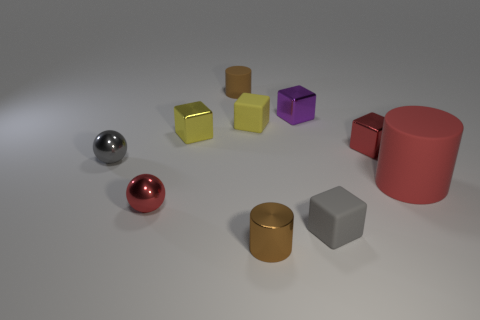What is the material of the large cylinder?
Provide a succinct answer. Rubber. There is a purple thing that is the same size as the gray sphere; what shape is it?
Your response must be concise. Cube. Is the small red object that is right of the yellow matte cube made of the same material as the brown object in front of the tiny purple cube?
Your answer should be compact. Yes. What number of small brown metallic objects are there?
Offer a terse response. 1. How many other matte objects are the same shape as the large red rubber object?
Ensure brevity in your answer.  1. Is the shape of the large rubber object the same as the small brown shiny thing?
Keep it short and to the point. Yes. The red rubber object has what size?
Your answer should be very brief. Large. How many red things are the same size as the brown rubber thing?
Keep it short and to the point. 2. Do the brown cylinder that is to the left of the brown metal cylinder and the gray rubber cube that is in front of the large red matte thing have the same size?
Provide a short and direct response. Yes. What shape is the gray object on the left side of the yellow metallic block?
Offer a terse response. Sphere. 